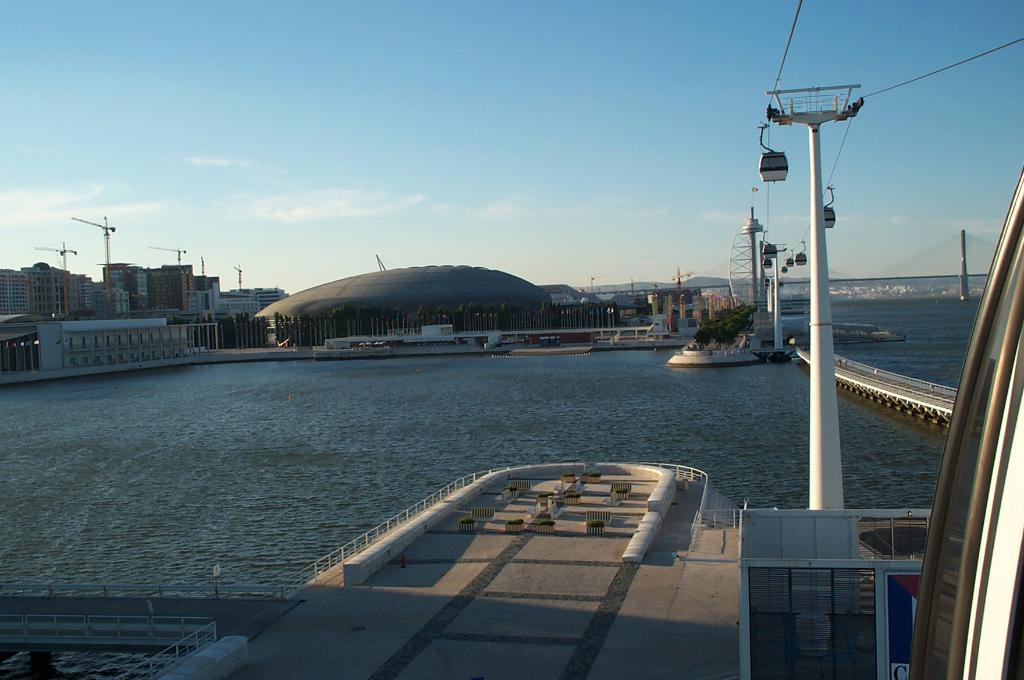What is the main subject in the center of the image? There is a boat in the center of the image. What can be seen in the background of the image? Sky, clouds, poles, buildings, a wall, a roof, water, and a fence are visible in the background of the image. Are there any other boats visible in the image? Yes, there are other boats visible in the background of the image. How many goldfish are swimming in the water in the image? There are no goldfish present in the image; it features a boat and various background elements. What type of muscle is being exercised by the boat in the image? The boat is an inanimate object and does not have muscles; the question is not applicable to the image. 